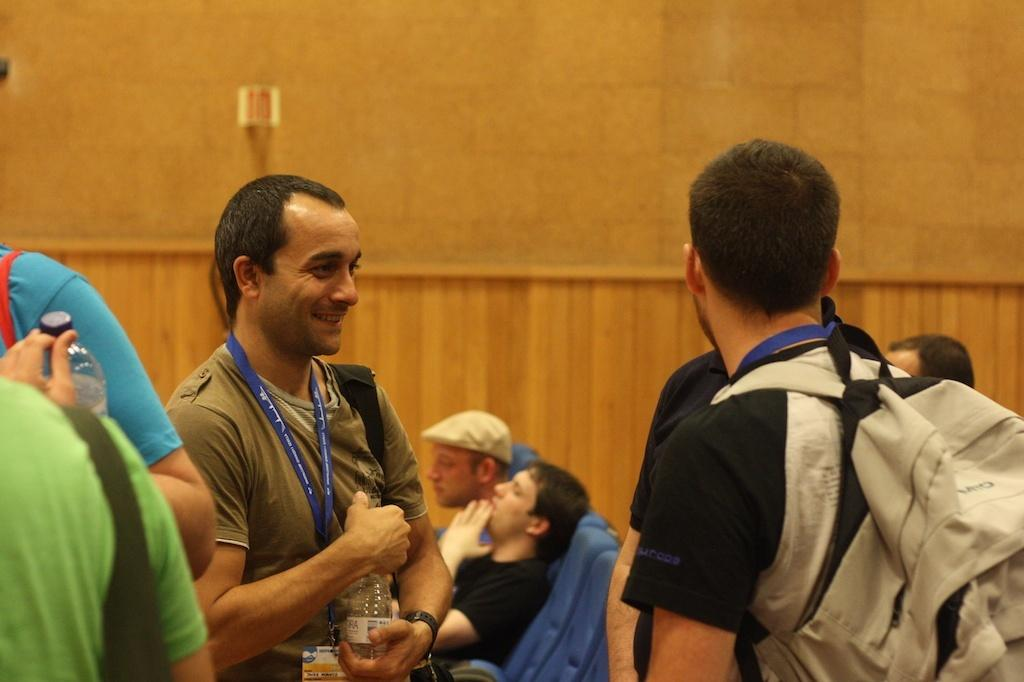What are the people in the image doing? The people in the image are standing. Can you describe the people in the background? In the background, there are people sitting on chairs. What can be seen in the image besides the people? There is a wall visible in the image. How many spiders are crawling on the mouth of the person in the image? There are no spiders present in the image, and no one's mouth is visible. 